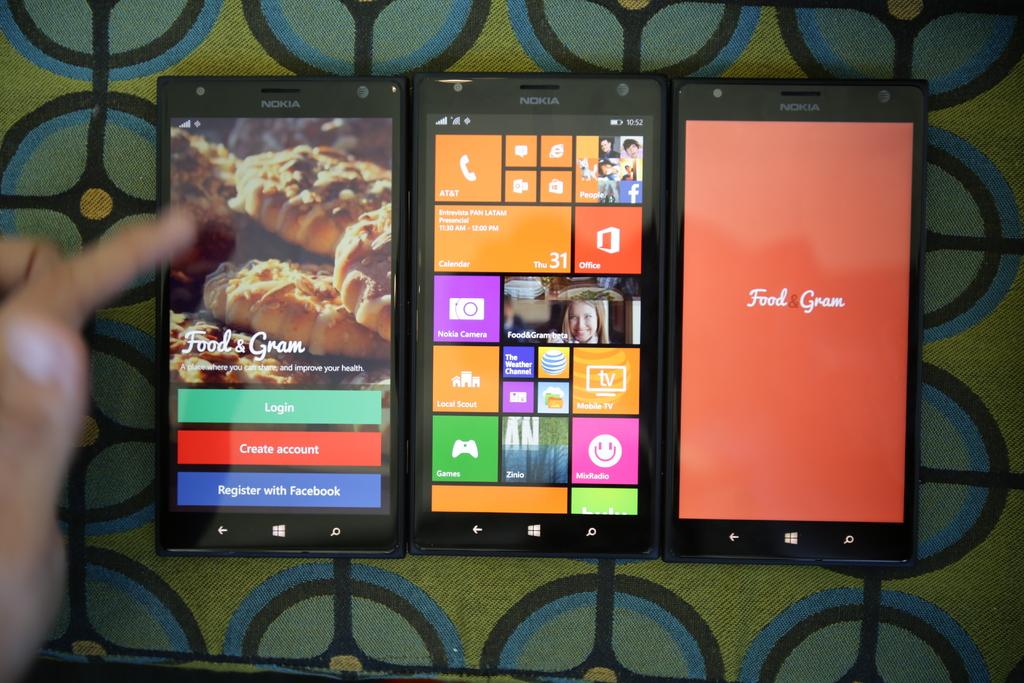What is the name of the app?
Offer a terse response. Food gram. What is the brand of tablet?
Offer a terse response. Nokia. 